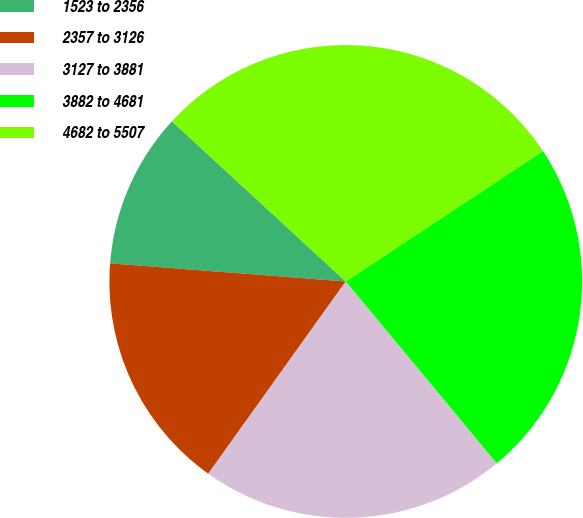Convert chart to OTSL. <chart><loc_0><loc_0><loc_500><loc_500><pie_chart><fcel>1523 to 2356<fcel>2357 to 3126<fcel>3127 to 3881<fcel>3882 to 4681<fcel>4682 to 5507<nl><fcel>10.63%<fcel>16.34%<fcel>20.91%<fcel>23.28%<fcel>28.85%<nl></chart> 